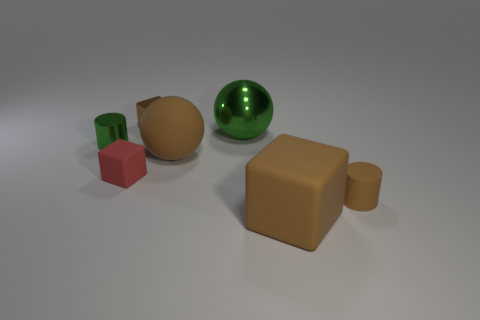Add 1 tiny cyan objects. How many objects exist? 8 Subtract all big brown blocks. How many blocks are left? 2 Subtract all brown spheres. How many brown blocks are left? 2 Subtract all brown matte spheres. Subtract all yellow objects. How many objects are left? 6 Add 2 tiny matte cylinders. How many tiny matte cylinders are left? 3 Add 3 big gray matte balls. How many big gray matte balls exist? 3 Subtract all brown cubes. How many cubes are left? 1 Subtract 0 purple cylinders. How many objects are left? 7 Subtract all cubes. How many objects are left? 4 Subtract 1 cylinders. How many cylinders are left? 1 